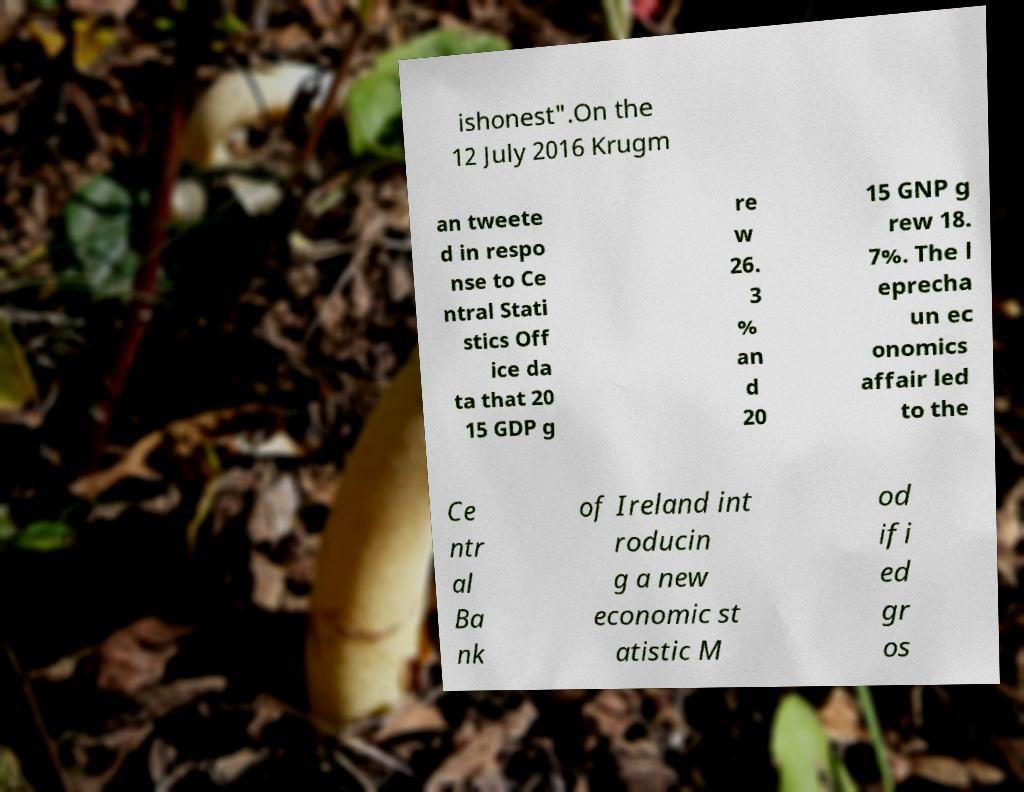Can you accurately transcribe the text from the provided image for me? ishonest".On the 12 July 2016 Krugm an tweete d in respo nse to Ce ntral Stati stics Off ice da ta that 20 15 GDP g re w 26. 3 % an d 20 15 GNP g rew 18. 7%. The l eprecha un ec onomics affair led to the Ce ntr al Ba nk of Ireland int roducin g a new economic st atistic M od ifi ed gr os 